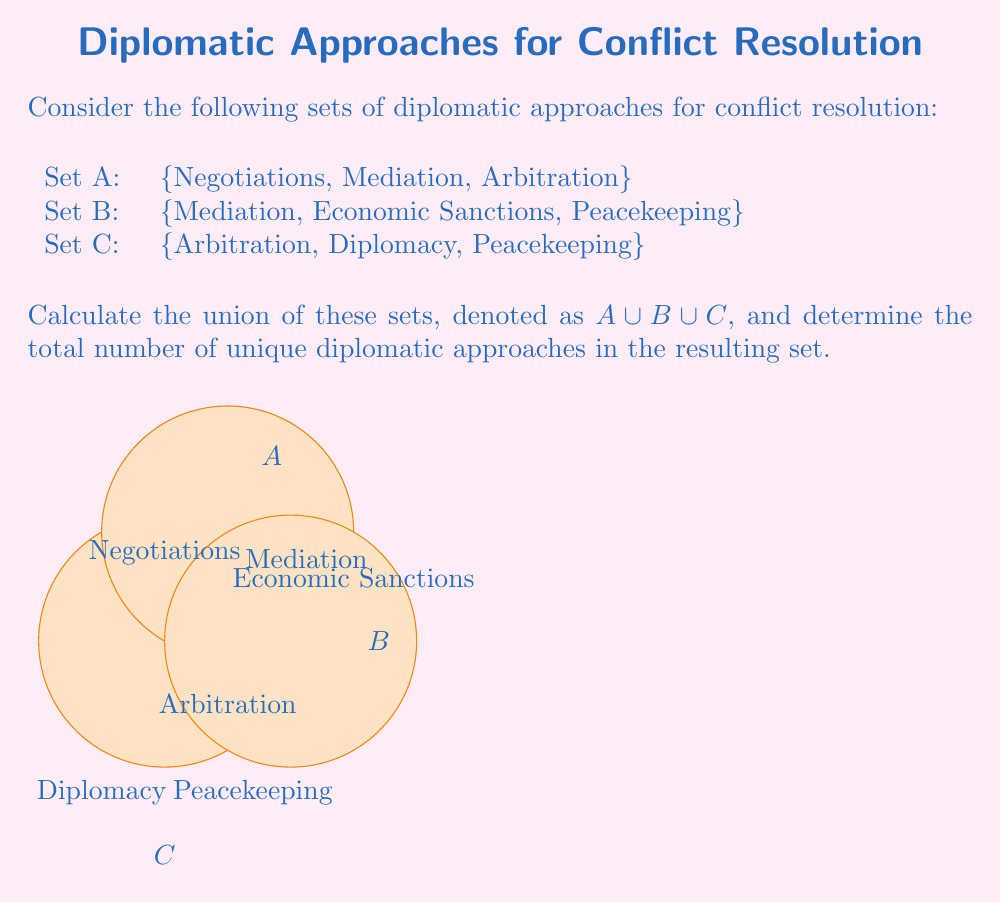Teach me how to tackle this problem. To solve this problem, we need to follow these steps:

1) First, let's identify the elements in each set:
   Set A: {Negotiations, Mediation, Arbitration}
   Set B: {Mediation, Economic Sanctions, Peacekeeping}
   Set C: {Arbitration, Diplomacy, Peacekeeping}

2) The union of these sets, $A \cup B \cup C$, will include all unique elements from all three sets.

3) Let's list out all elements, removing duplicates:
   - Negotiations (from A)
   - Mediation (from A and B)
   - Arbitration (from A and C)
   - Economic Sanctions (from B)
   - Peacekeeping (from B and C)
   - Diplomacy (from C)

4) Count the unique elements in the resulting set:
   $|A \cup B \cup C| = 6$

Therefore, the union of the three sets contains 6 unique diplomatic approaches for conflict resolution.
Answer: $|A \cup B \cup C| = 6$ 